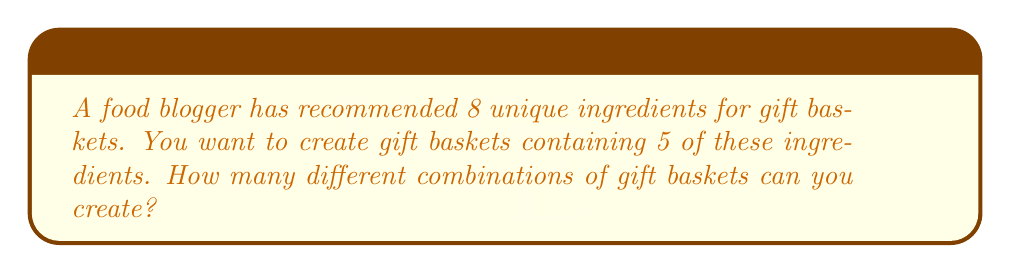Can you answer this question? Let's approach this step-by-step:

1) This is a combination problem. We are selecting 5 items from a set of 8, where the order doesn't matter (it's the same gift basket regardless of the order we put the ingredients in).

2) The formula for combinations is:

   $$C(n,r) = \frac{n!}{r!(n-r)!}$$

   Where $n$ is the total number of items to choose from, and $r$ is the number of items being chosen.

3) In this case, $n = 8$ (total unique ingredients) and $r = 5$ (ingredients per basket).

4) Substituting these values into our formula:

   $$C(8,5) = \frac{8!}{5!(8-5)!} = \frac{8!}{5!3!}$$

5) Let's calculate this:
   
   $$\frac{8 \cdot 7 \cdot 6 \cdot 5!}{5! \cdot 3 \cdot 2 \cdot 1}$$

6) The 5! cancels out in the numerator and denominator:

   $$\frac{8 \cdot 7 \cdot 6}{3 \cdot 2 \cdot 1} = \frac{336}{6} = 56$$

Therefore, you can create 56 different combinations of gift baskets.
Answer: 56 